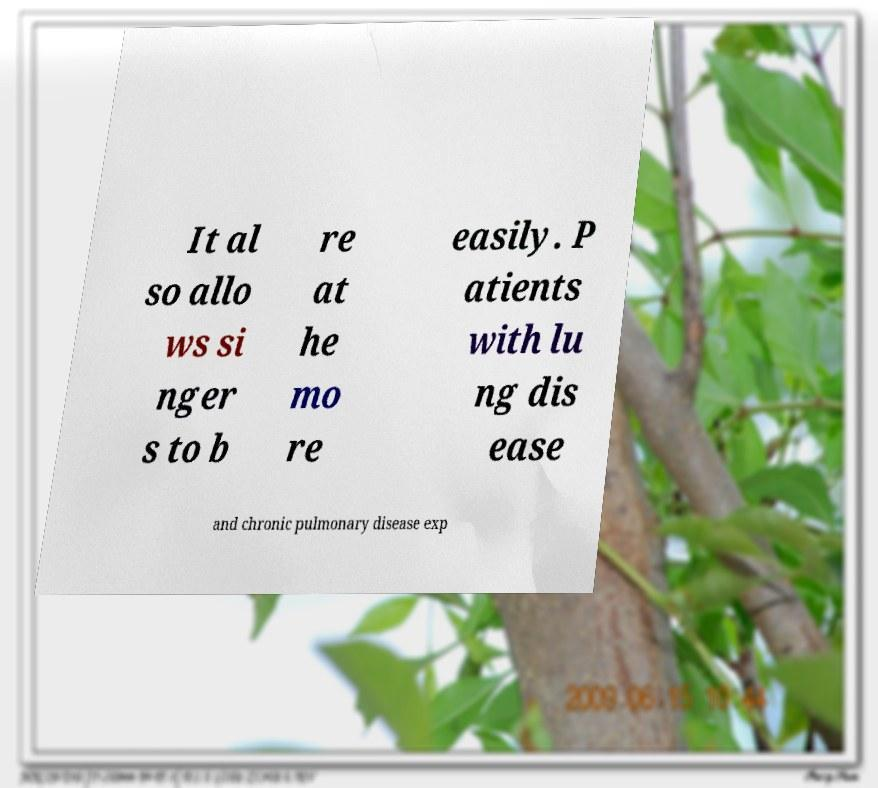Please read and relay the text visible in this image. What does it say? It al so allo ws si nger s to b re at he mo re easily. P atients with lu ng dis ease and chronic pulmonary disease exp 